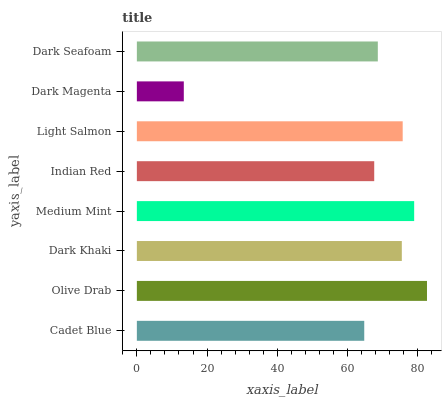Is Dark Magenta the minimum?
Answer yes or no. Yes. Is Olive Drab the maximum?
Answer yes or no. Yes. Is Dark Khaki the minimum?
Answer yes or no. No. Is Dark Khaki the maximum?
Answer yes or no. No. Is Olive Drab greater than Dark Khaki?
Answer yes or no. Yes. Is Dark Khaki less than Olive Drab?
Answer yes or no. Yes. Is Dark Khaki greater than Olive Drab?
Answer yes or no. No. Is Olive Drab less than Dark Khaki?
Answer yes or no. No. Is Dark Khaki the high median?
Answer yes or no. Yes. Is Dark Seafoam the low median?
Answer yes or no. Yes. Is Indian Red the high median?
Answer yes or no. No. Is Olive Drab the low median?
Answer yes or no. No. 